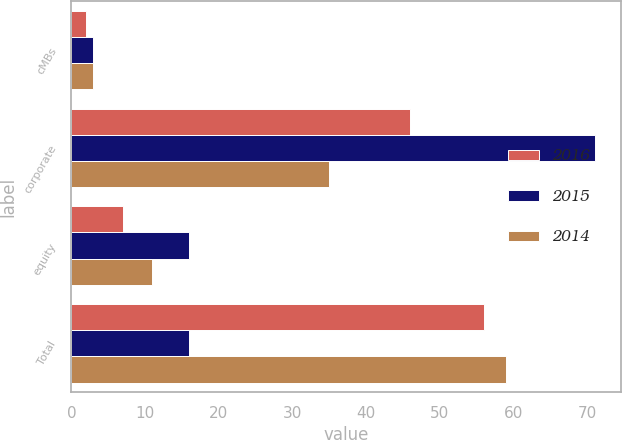<chart> <loc_0><loc_0><loc_500><loc_500><stacked_bar_chart><ecel><fcel>cMBs<fcel>corporate<fcel>equity<fcel>Total<nl><fcel>2016<fcel>2<fcel>46<fcel>7<fcel>56<nl><fcel>2015<fcel>3<fcel>71<fcel>16<fcel>16<nl><fcel>2014<fcel>3<fcel>35<fcel>11<fcel>59<nl></chart> 